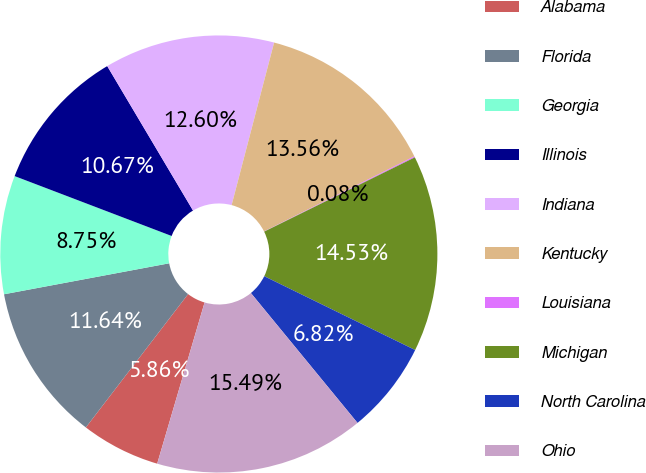Convert chart. <chart><loc_0><loc_0><loc_500><loc_500><pie_chart><fcel>Alabama<fcel>Florida<fcel>Georgia<fcel>Illinois<fcel>Indiana<fcel>Kentucky<fcel>Louisiana<fcel>Michigan<fcel>North Carolina<fcel>Ohio<nl><fcel>5.86%<fcel>11.64%<fcel>8.75%<fcel>10.67%<fcel>12.6%<fcel>13.56%<fcel>0.08%<fcel>14.53%<fcel>6.82%<fcel>15.49%<nl></chart> 